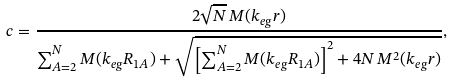<formula> <loc_0><loc_0><loc_500><loc_500>c = \frac { 2 \sqrt { N } \, M ( k _ { e g } r ) } { \sum _ { A = 2 } ^ { N } M ( k _ { e g } R _ { 1 A } ) + \sqrt { \left [ \sum _ { A = 2 } ^ { N } M ( k _ { e g } R _ { 1 A } ) \right ] ^ { 2 } + 4 N \, M ^ { 2 } ( k _ { e g } r ) } } ,</formula> 